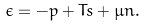Convert formula to latex. <formula><loc_0><loc_0><loc_500><loc_500>\epsilon = - p + T s + \mu n .</formula> 